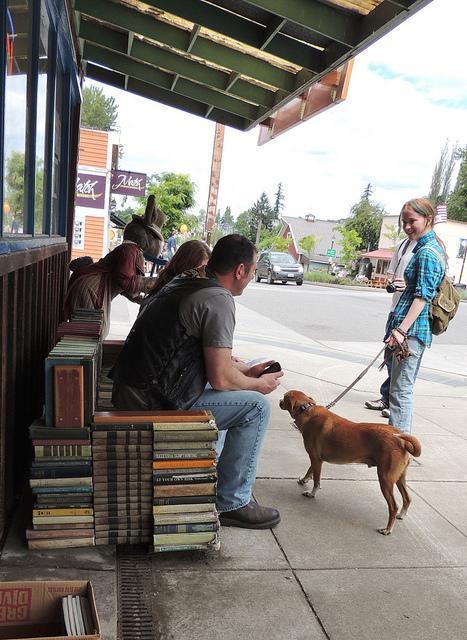From which room could items used to make this chair originate?
Pick the correct solution from the four options below to address the question.
Options: Library, kitchen, dining room, sewing room. Library. Why are they sitting on a pile of books?
Make your selection from the four choices given to correctly answer the question.
Options: Their job, found, is bookstore, are stolen. Is bookstore. 